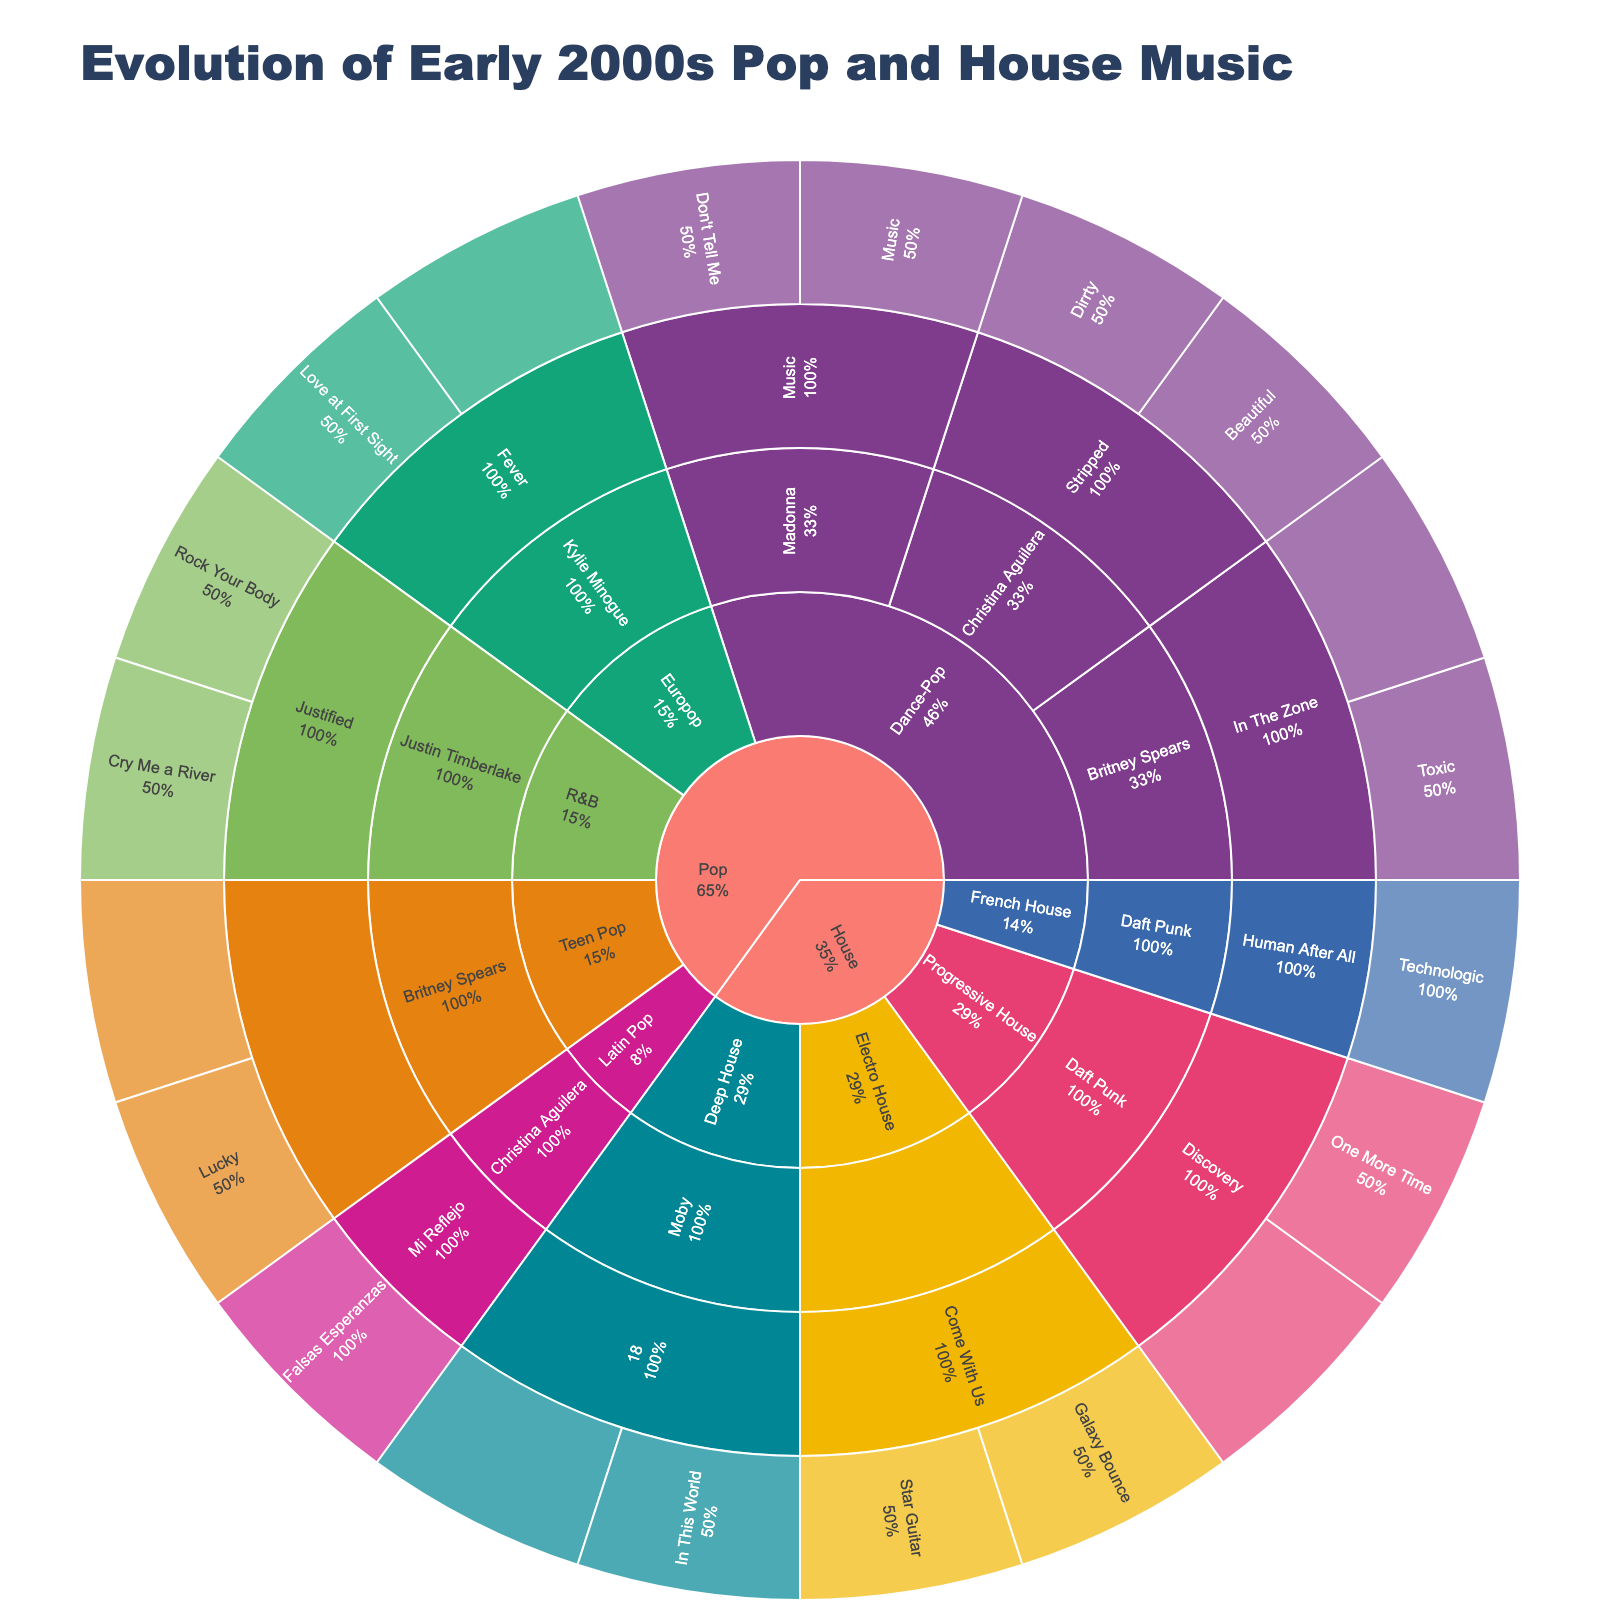What's the title of the figure? The title is displayed at the top of the figure. It provides a summary of what is being visualized.
Answer: Evolution of Early 2000s Pop and House Music How many songs does Britney Spears have in this chart? To find the number of songs by Britney Spears, navigate through the levels: Pop -> Dance-Pop -> Britney Spears and Pop -> Teen Pop -> Britney Spears. Add up the songs under each branch.
Answer: 4 Which artist has the most songs in this chart? Identify the artist with the largest number of segments (songs) under their name across all levels of the Sunburst plot. Compare them to find the one with the most songs.
Answer: Daft Punk How many genres are displayed in the figure? Count the unique genre segments branching out from both the "Pop" and "House" categories. Each genre represents a unique segment directly under these two categories.
Answer: 9 Which genre has the highest representation of songs? Explore each genre's extension from the "Pop" and "House" categories. Count the number of song segments under each genre and identify the one with the highest count.
Answer: Dance-Pop What percentage of Pop songs in the chart are sung by Christina Aguilera? Navigate to the Pop category, then down to each genre level and sum up all Pop songs. Find Christina Aguilera's songs and compute the ratio compared to the total Pop songs, then multiply by 100 to get the percentage.
Answer: 20% Which album by Daft Punk has the most songs? By tracing Daft Punk’s path, count the number of songs listed under each of their albums and identify the album with the highest count.
Answer: Discovery Is the number of songs by each Pop artist equally distributed? Check each Pop artist's corresponding segments, count the songs, and compare the totals to see if there's an equal or unequal distribution.
Answer: No How many unique albums are there in this chart? Count all the distinct album segments in the Sunburst plot after navigating through all genre and artist branches. Each unique segment represents a different album.
Answer: 11 Which category, Pop or House, has more songs in total? Sum the number of songs branching from the Pop category and the House category independently. Compare the two sums to find out which category has more songs.
Answer: Pop 